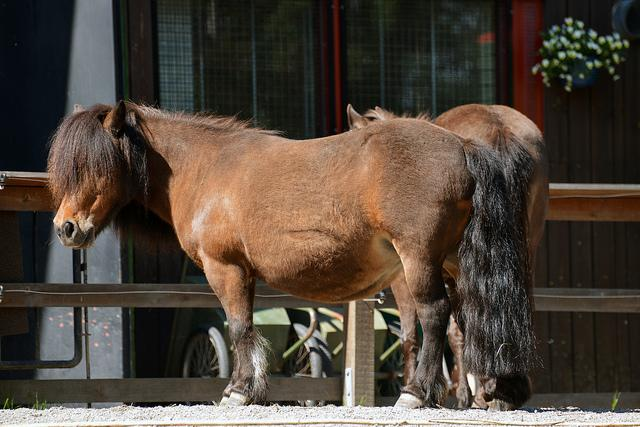What type of horse is this? shetland pony 